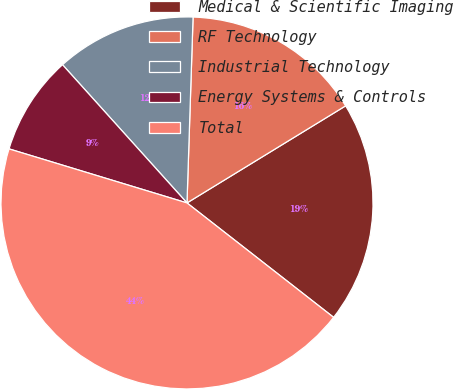<chart> <loc_0><loc_0><loc_500><loc_500><pie_chart><fcel>Medical & Scientific Imaging<fcel>RF Technology<fcel>Industrial Technology<fcel>Energy Systems & Controls<fcel>Total<nl><fcel>19.29%<fcel>15.74%<fcel>12.19%<fcel>8.64%<fcel>44.15%<nl></chart> 